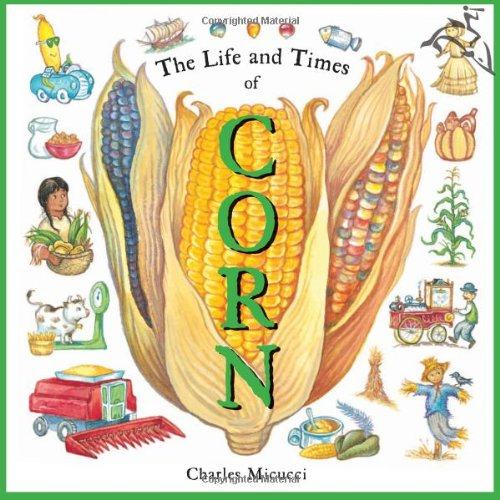What is the title of this book? The book is titled 'The Life and Times of Corn', which delves into the cultural, economic, and botanical aspects of corn, presented in a colorful and accessible format for children. 